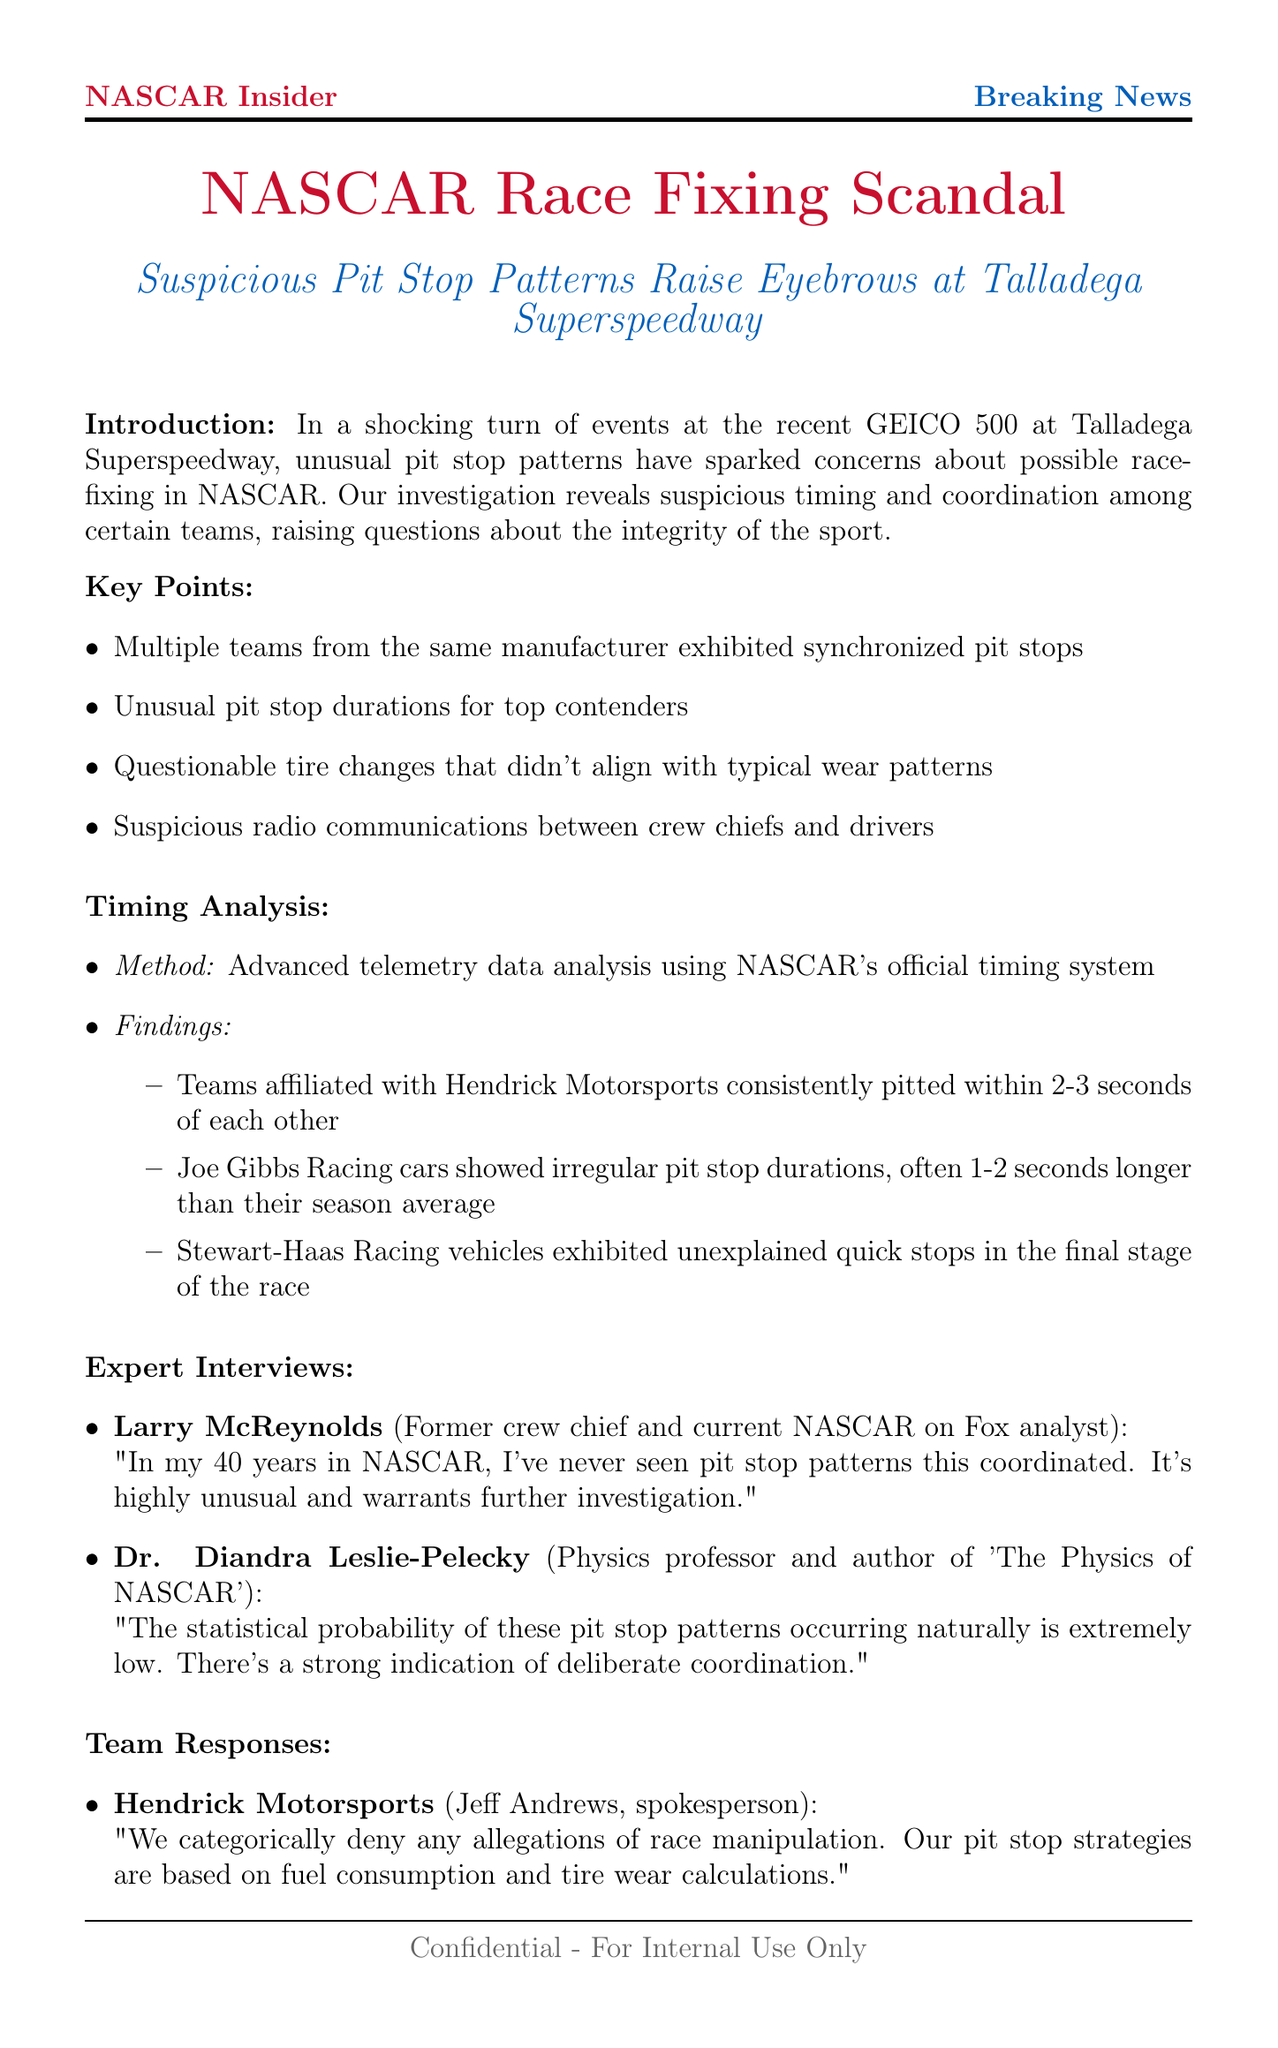What unusual patterns were noted during the GEICO 500? The document mentions unusual pit stop patterns sparked concerns about possible race-fixing in NASCAR.
Answer: Suspicious pit stop patterns How many seconds did teams from Hendrick Motorsports consistently pit within of each other? The timing analysis found that teams from Hendrick Motorsports consistently pitted within 2-3 seconds of each other.
Answer: 2-3 seconds Who is the spokesperson for Joe Gibbs Racing? The document names Dave Alpern as the spokesperson for Joe Gibbs Racing.
Answer: Dave Alpern What did Dr. Diandra Leslie-Pelecky say about the probability of the pit stop patterns? The expert quoted indicates that the statistical probability of these patterns occurring naturally is extremely low.
Answer: Extremely low What are potential consequences mentioned for teams involved in the alleged manipulation? The document lists several potential implications, such as fines and point deductions for involved teams.
Answer: Fines and point deductions How long has Larry McReynolds been involved in NASCAR? The document states that Larry McReynolds has 40 years of experience in NASCAR.
Answer: 40 years What was NASCAR's response regarding the allegations? The document states that NASCAR's official position emphasizes taking these allegations seriously and conducting a thorough investigation.
Answer: Conducting a thorough investigation Which racing teams showed irregular pit stop durations? The timing analysis indicated that Joe Gibbs Racing cars showed irregular pit stop durations.
Answer: Joe Gibbs Racing What is the title of the newsletter? The document emphasizes the theme of race-fixing in NASCAR.
Answer: NASCAR Race Fixing Scandal 